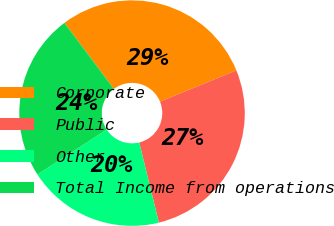Convert chart. <chart><loc_0><loc_0><loc_500><loc_500><pie_chart><fcel>Corporate<fcel>Public<fcel>Other<fcel>Total Income from operations<nl><fcel>29.06%<fcel>27.35%<fcel>19.66%<fcel>23.93%<nl></chart> 